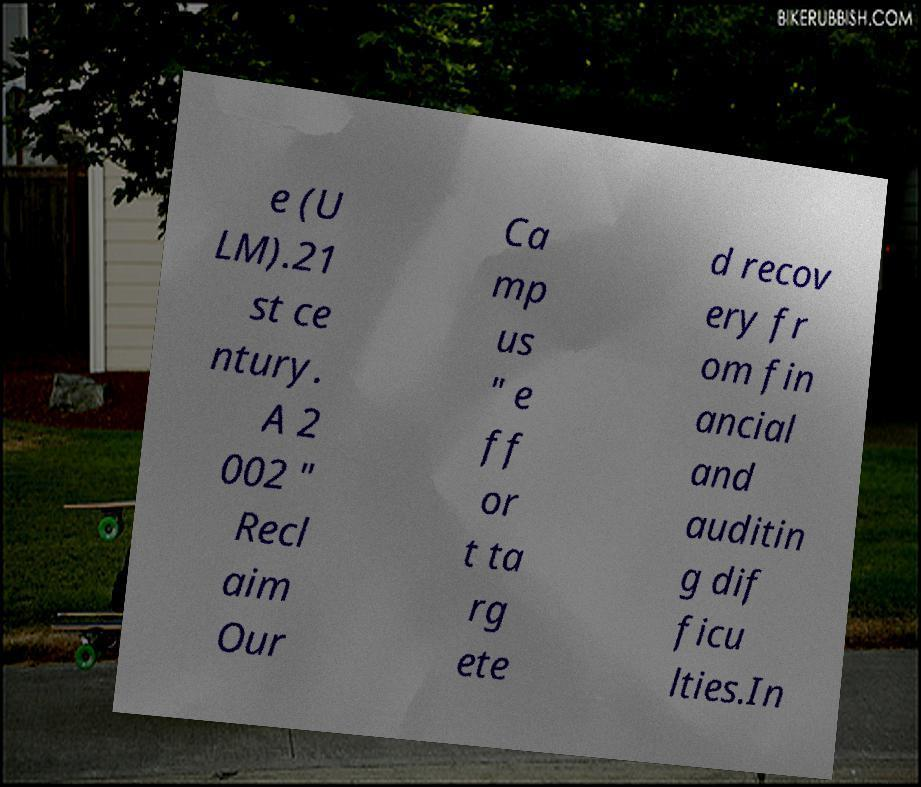Could you extract and type out the text from this image? e (U LM).21 st ce ntury. A 2 002 " Recl aim Our Ca mp us " e ff or t ta rg ete d recov ery fr om fin ancial and auditin g dif ficu lties.In 